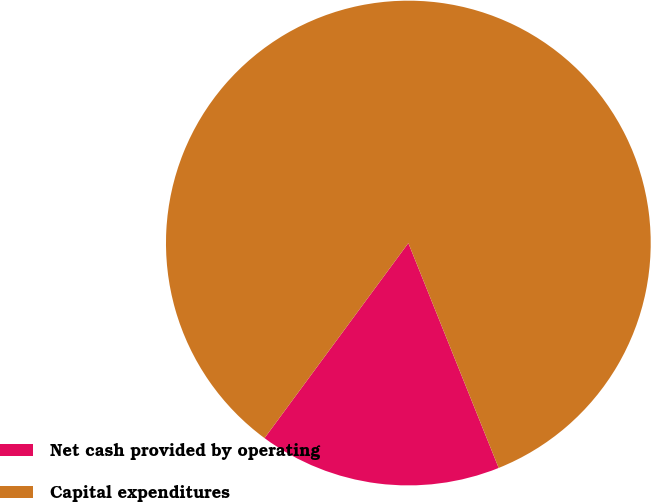<chart> <loc_0><loc_0><loc_500><loc_500><pie_chart><fcel>Net cash provided by operating<fcel>Capital expenditures<nl><fcel>16.19%<fcel>83.81%<nl></chart> 